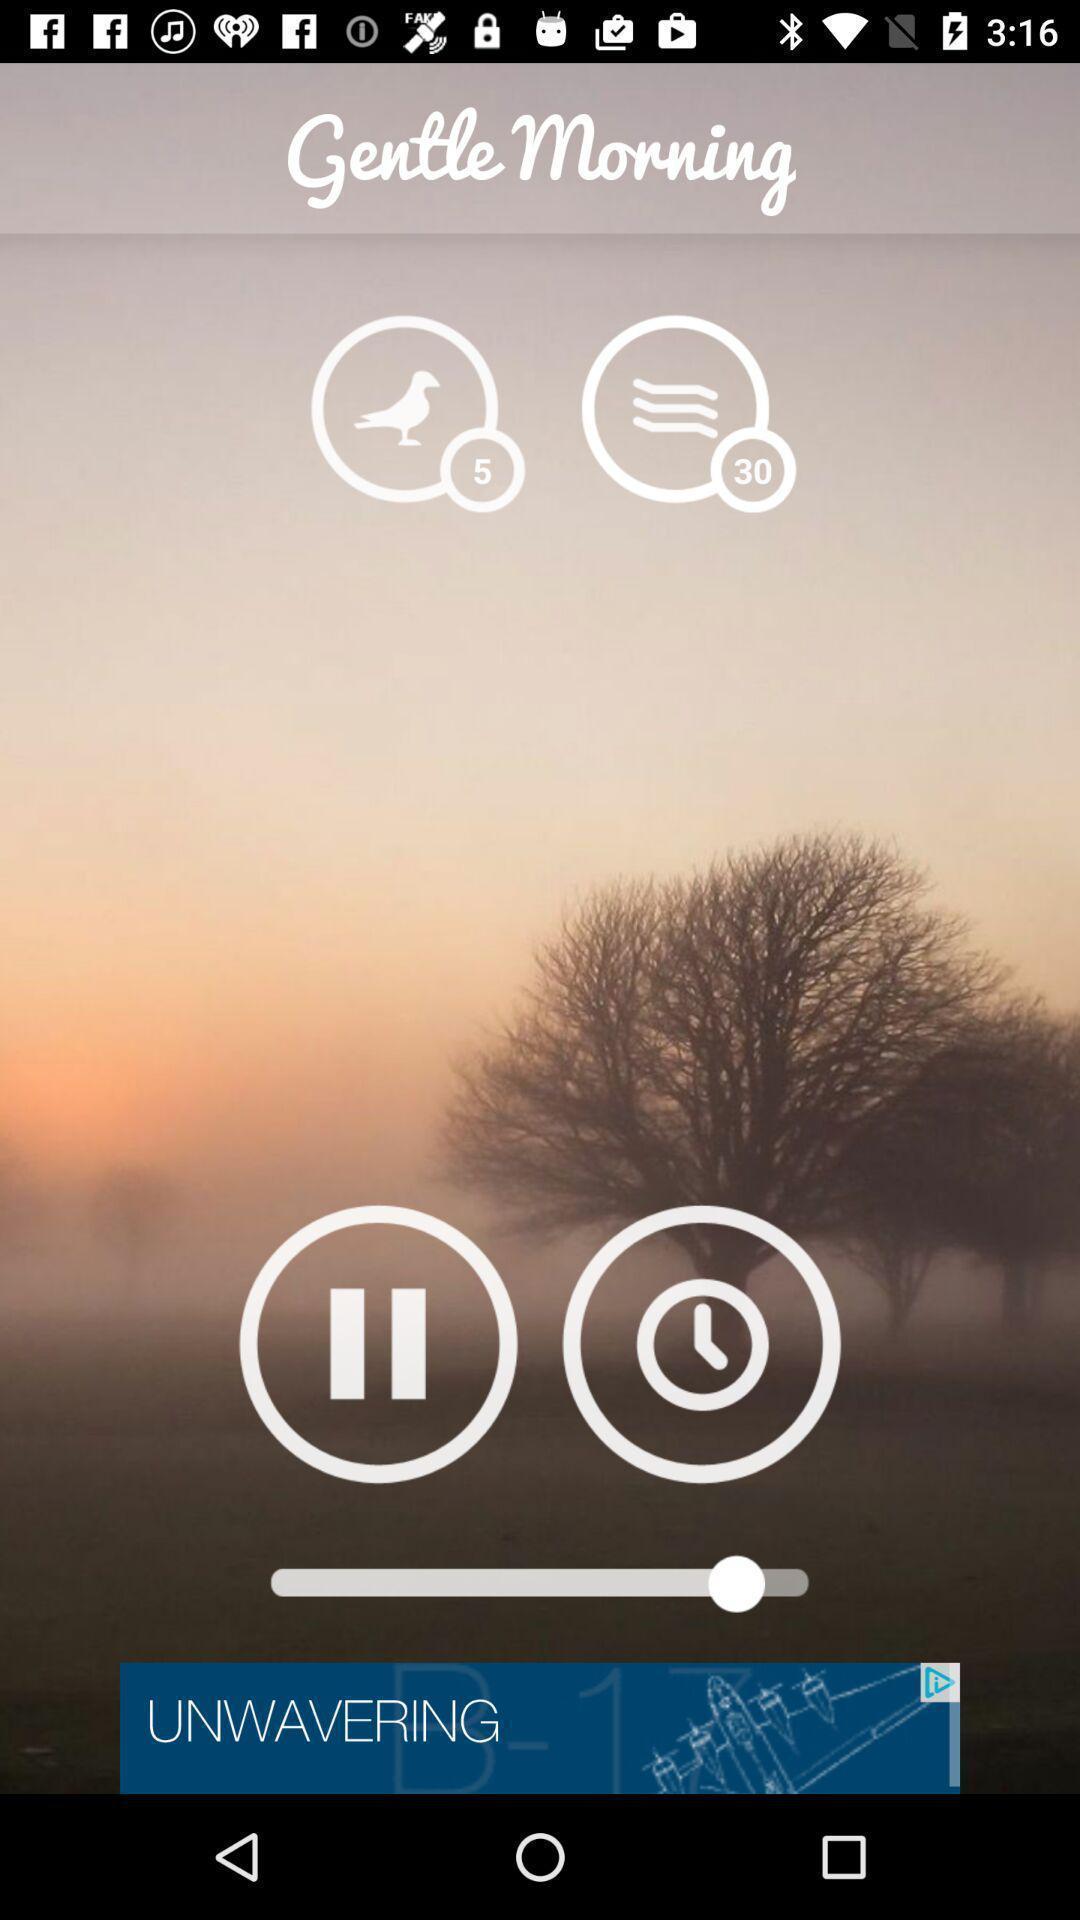What is the overall content of this screenshot? Screen showing page. 